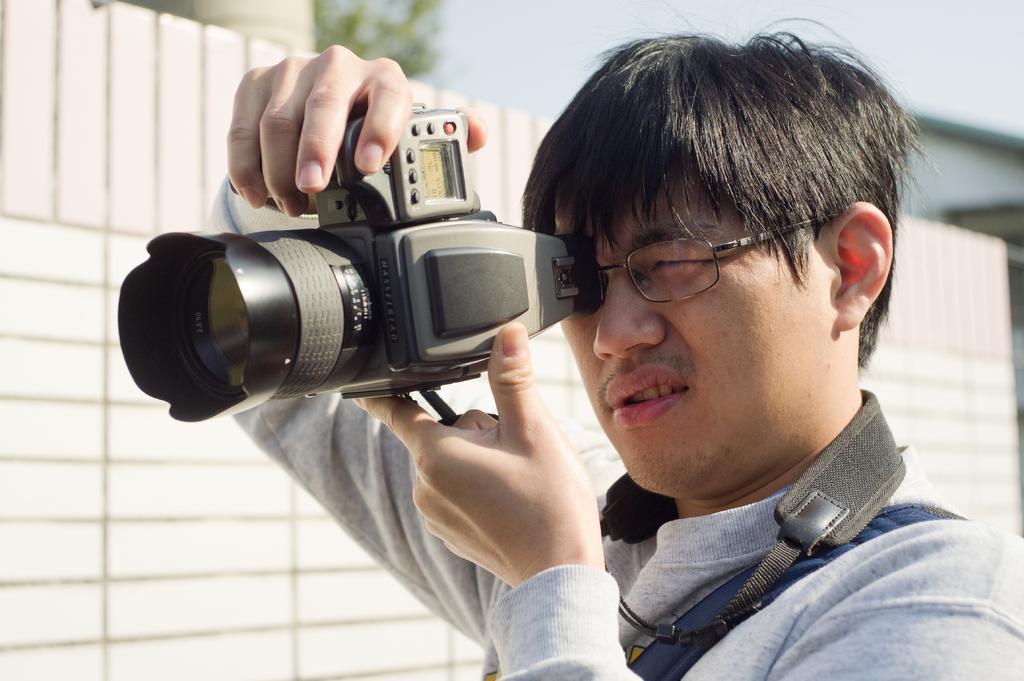Describe this image in one or two sentences. In this picture we can see a man is holding a digital camera and taking a picture of something, on the left side we can see wooden fencing and on the top left corner we can see a tree. 